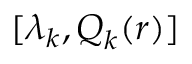<formula> <loc_0><loc_0><loc_500><loc_500>[ \lambda _ { k } , Q _ { k } ( r ) ]</formula> 